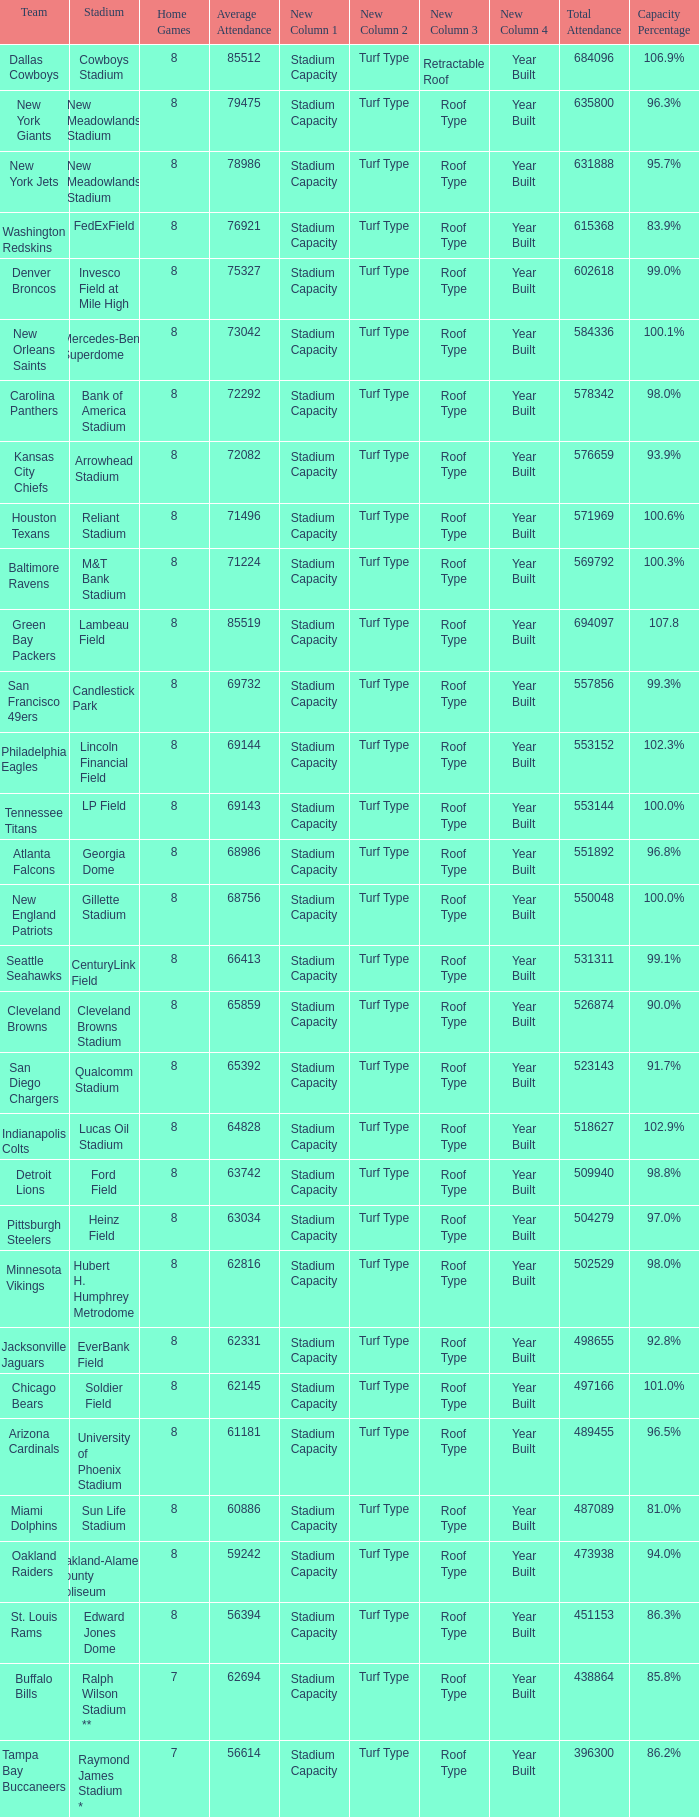How many home games are listed when the average attendance is 79475? 1.0. 